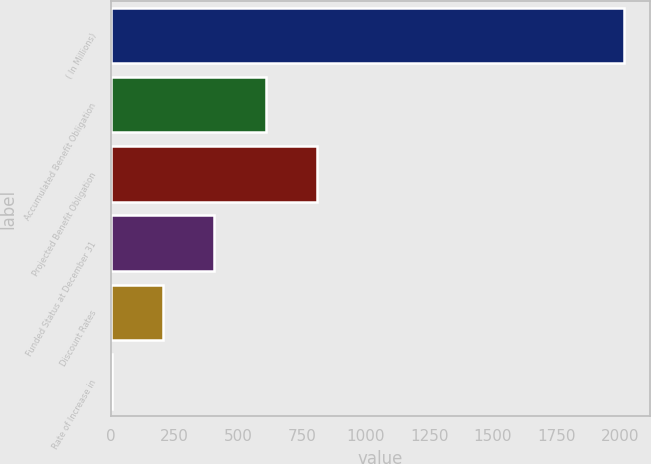Convert chart. <chart><loc_0><loc_0><loc_500><loc_500><bar_chart><fcel>( In Millions)<fcel>Accumulated Benefit Obligation<fcel>Projected Benefit Obligation<fcel>Funded Status at December 31<fcel>Discount Rates<fcel>Rate of Increase in<nl><fcel>2018<fcel>606.62<fcel>808.25<fcel>405<fcel>203.38<fcel>1.75<nl></chart> 